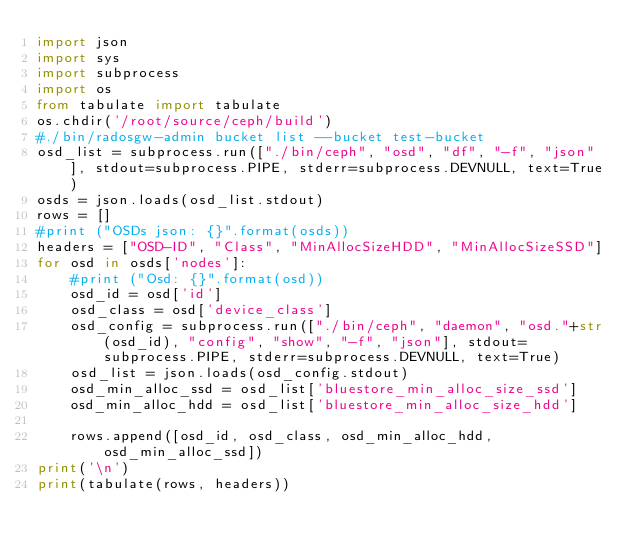Convert code to text. <code><loc_0><loc_0><loc_500><loc_500><_Python_>import json
import sys
import subprocess
import os
from tabulate import tabulate
os.chdir('/root/source/ceph/build')
#./bin/radosgw-admin bucket list --bucket test-bucket
osd_list = subprocess.run(["./bin/ceph", "osd", "df", "-f", "json"], stdout=subprocess.PIPE, stderr=subprocess.DEVNULL, text=True)
osds = json.loads(osd_list.stdout)
rows = []
#print ("OSDs json: {}".format(osds))
headers = ["OSD-ID", "Class", "MinAllocSizeHDD", "MinAllocSizeSSD"]
for osd in osds['nodes']:
    #print ("Osd: {}".format(osd))
    osd_id = osd['id']
    osd_class = osd['device_class']
    osd_config = subprocess.run(["./bin/ceph", "daemon", "osd."+str(osd_id), "config", "show", "-f", "json"], stdout=subprocess.PIPE, stderr=subprocess.DEVNULL, text=True)
    osd_list = json.loads(osd_config.stdout)
    osd_min_alloc_ssd = osd_list['bluestore_min_alloc_size_ssd']
    osd_min_alloc_hdd = osd_list['bluestore_min_alloc_size_hdd']

    rows.append([osd_id, osd_class, osd_min_alloc_hdd, osd_min_alloc_ssd])
print('\n')
print(tabulate(rows, headers))

</code> 